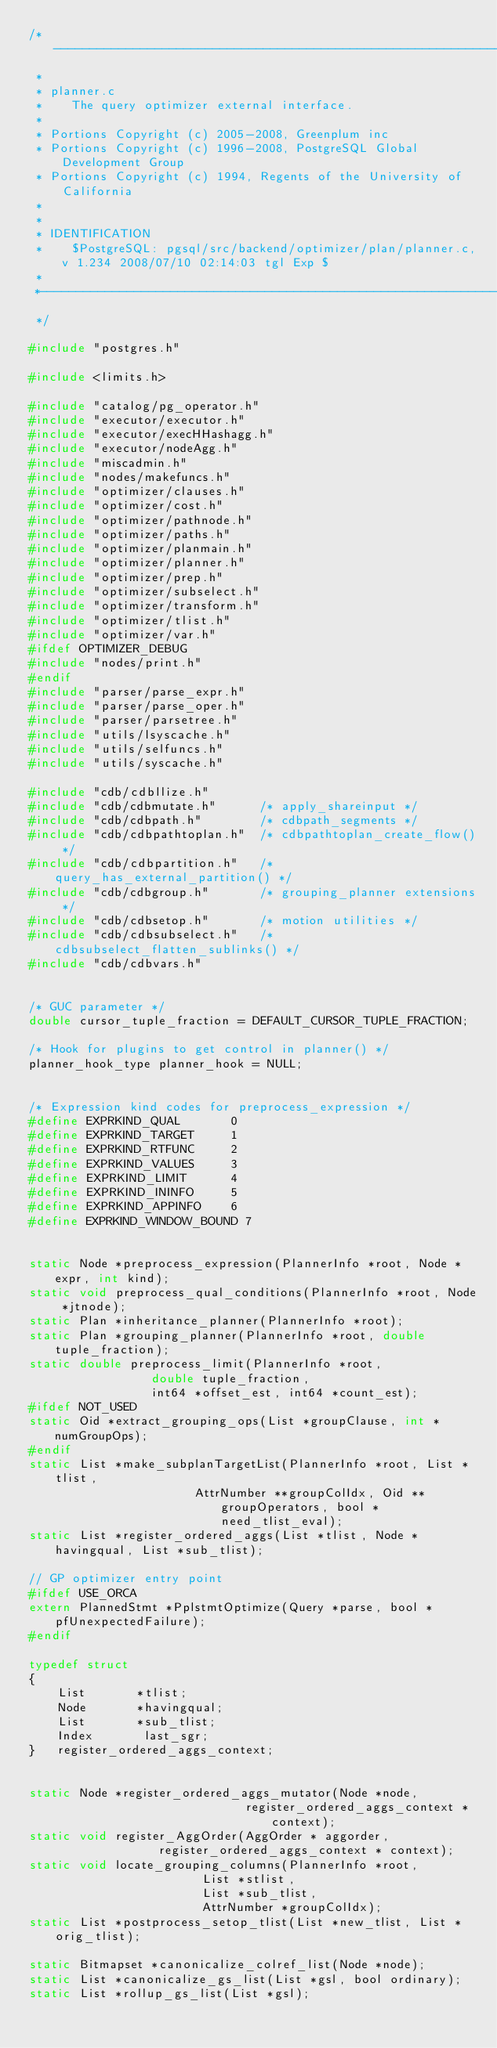Convert code to text. <code><loc_0><loc_0><loc_500><loc_500><_C_>/*-------------------------------------------------------------------------
 *
 * planner.c
 *	  The query optimizer external interface.
 *
 * Portions Copyright (c) 2005-2008, Greenplum inc
 * Portions Copyright (c) 1996-2008, PostgreSQL Global Development Group
 * Portions Copyright (c) 1994, Regents of the University of California
 *
 *
 * IDENTIFICATION
 *	  $PostgreSQL: pgsql/src/backend/optimizer/plan/planner.c,v 1.234 2008/07/10 02:14:03 tgl Exp $
 *
 *-------------------------------------------------------------------------
 */

#include "postgres.h"

#include <limits.h>

#include "catalog/pg_operator.h"
#include "executor/executor.h"
#include "executor/execHHashagg.h"
#include "executor/nodeAgg.h"
#include "miscadmin.h"
#include "nodes/makefuncs.h"
#include "optimizer/clauses.h"
#include "optimizer/cost.h"
#include "optimizer/pathnode.h"
#include "optimizer/paths.h"
#include "optimizer/planmain.h"
#include "optimizer/planner.h"
#include "optimizer/prep.h"
#include "optimizer/subselect.h"
#include "optimizer/transform.h"
#include "optimizer/tlist.h"
#include "optimizer/var.h"
#ifdef OPTIMIZER_DEBUG
#include "nodes/print.h"
#endif
#include "parser/parse_expr.h"
#include "parser/parse_oper.h"
#include "parser/parsetree.h"
#include "utils/lsyscache.h"
#include "utils/selfuncs.h"
#include "utils/syscache.h"

#include "cdb/cdbllize.h"
#include "cdb/cdbmutate.h"		/* apply_shareinput */
#include "cdb/cdbpath.h"		/* cdbpath_segments */
#include "cdb/cdbpathtoplan.h"	/* cdbpathtoplan_create_flow() */
#include "cdb/cdbpartition.h"	/* query_has_external_partition() */
#include "cdb/cdbgroup.h"		/* grouping_planner extensions */
#include "cdb/cdbsetop.h"		/* motion utilities */
#include "cdb/cdbsubselect.h"	/* cdbsubselect_flatten_sublinks() */
#include "cdb/cdbvars.h"


/* GUC parameter */
double cursor_tuple_fraction = DEFAULT_CURSOR_TUPLE_FRACTION;

/* Hook for plugins to get control in planner() */
planner_hook_type planner_hook = NULL;


/* Expression kind codes for preprocess_expression */
#define EXPRKIND_QUAL		0
#define EXPRKIND_TARGET		1
#define EXPRKIND_RTFUNC		2
#define EXPRKIND_VALUES		3
#define EXPRKIND_LIMIT		4
#define EXPRKIND_ININFO		5
#define EXPRKIND_APPINFO	6
#define EXPRKIND_WINDOW_BOUND 7


static Node *preprocess_expression(PlannerInfo *root, Node *expr, int kind);
static void preprocess_qual_conditions(PlannerInfo *root, Node *jtnode);
static Plan *inheritance_planner(PlannerInfo *root);
static Plan *grouping_planner(PlannerInfo *root, double tuple_fraction);
static double preprocess_limit(PlannerInfo *root,
				 double tuple_fraction,
				 int64 *offset_est, int64 *count_est);
#ifdef NOT_USED
static Oid *extract_grouping_ops(List *groupClause, int *numGroupOps);
#endif
static List *make_subplanTargetList(PlannerInfo *root, List *tlist,
					   AttrNumber **groupColIdx, Oid **groupOperators, bool *need_tlist_eval);
static List *register_ordered_aggs(List *tlist, Node *havingqual, List *sub_tlist);

// GP optimizer entry point
#ifdef USE_ORCA
extern PlannedStmt *PplstmtOptimize(Query *parse, bool *pfUnexpectedFailure);
#endif

typedef struct
{
	List	   *tlist;
	Node	   *havingqual;
	List	   *sub_tlist;
	Index		last_sgr;
}	register_ordered_aggs_context;


static Node *register_ordered_aggs_mutator(Node *node,
							  register_ordered_aggs_context * context);
static void register_AggOrder(AggOrder * aggorder,
				  register_ordered_aggs_context * context);
static void locate_grouping_columns(PlannerInfo *root,
						List *stlist,
						List *sub_tlist,
						AttrNumber *groupColIdx);
static List *postprocess_setop_tlist(List *new_tlist, List *orig_tlist);

static Bitmapset *canonicalize_colref_list(Node *node);
static List *canonicalize_gs_list(List *gsl, bool ordinary);
static List *rollup_gs_list(List *gsl);</code> 